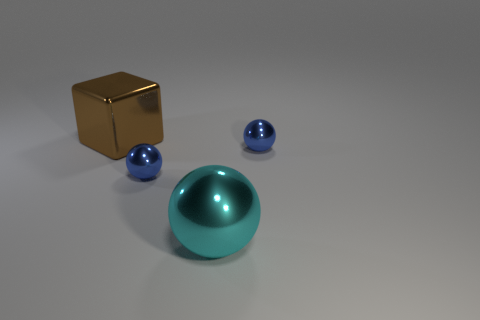Does the big brown thing have the same shape as the big cyan thing?
Provide a succinct answer. No. How many spheres are large brown shiny objects or small objects?
Offer a very short reply. 2. There is a large thing that is made of the same material as the block; what color is it?
Keep it short and to the point. Cyan. Does the metallic ball that is on the left side of the cyan shiny ball have the same size as the brown object?
Give a very brief answer. No. Do the brown thing and the blue object that is to the right of the big cyan sphere have the same material?
Your response must be concise. Yes. What is the color of the large cube that is behind the cyan ball?
Your answer should be compact. Brown. There is a big shiny object to the right of the large brown metallic thing; are there any small shiny spheres that are in front of it?
Provide a short and direct response. No. There is a metal sphere that is on the right side of the large sphere; is its color the same as the big thing that is in front of the large brown shiny thing?
Provide a succinct answer. No. There is a brown object; how many small blue balls are behind it?
Your response must be concise. 0. How many shiny things have the same color as the large block?
Keep it short and to the point. 0. 